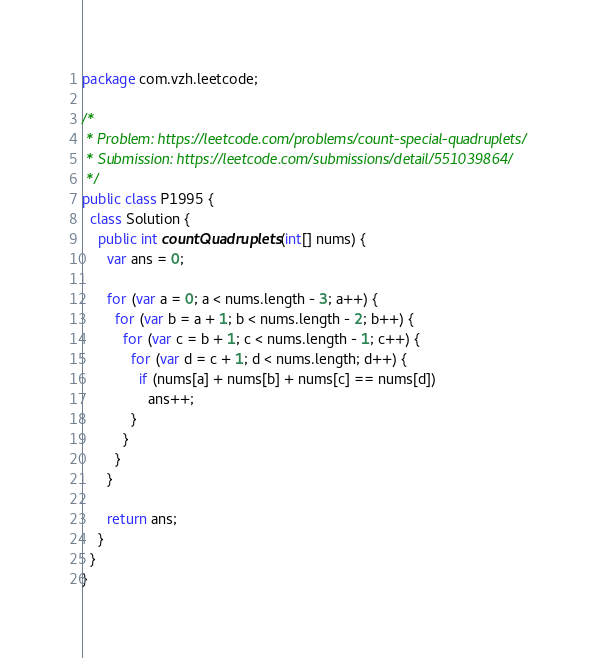Convert code to text. <code><loc_0><loc_0><loc_500><loc_500><_Java_>package com.vzh.leetcode;

/*
 * Problem: https://leetcode.com/problems/count-special-quadruplets/
 * Submission: https://leetcode.com/submissions/detail/551039864/
 */
public class P1995 {
  class Solution {
    public int countQuadruplets(int[] nums) {
      var ans = 0;

      for (var a = 0; a < nums.length - 3; a++) {
        for (var b = a + 1; b < nums.length - 2; b++) {
          for (var c = b + 1; c < nums.length - 1; c++) {
            for (var d = c + 1; d < nums.length; d++) {
              if (nums[a] + nums[b] + nums[c] == nums[d])
                ans++;
            }
          }
        }
      }

      return ans;
    }
  }
}</code> 